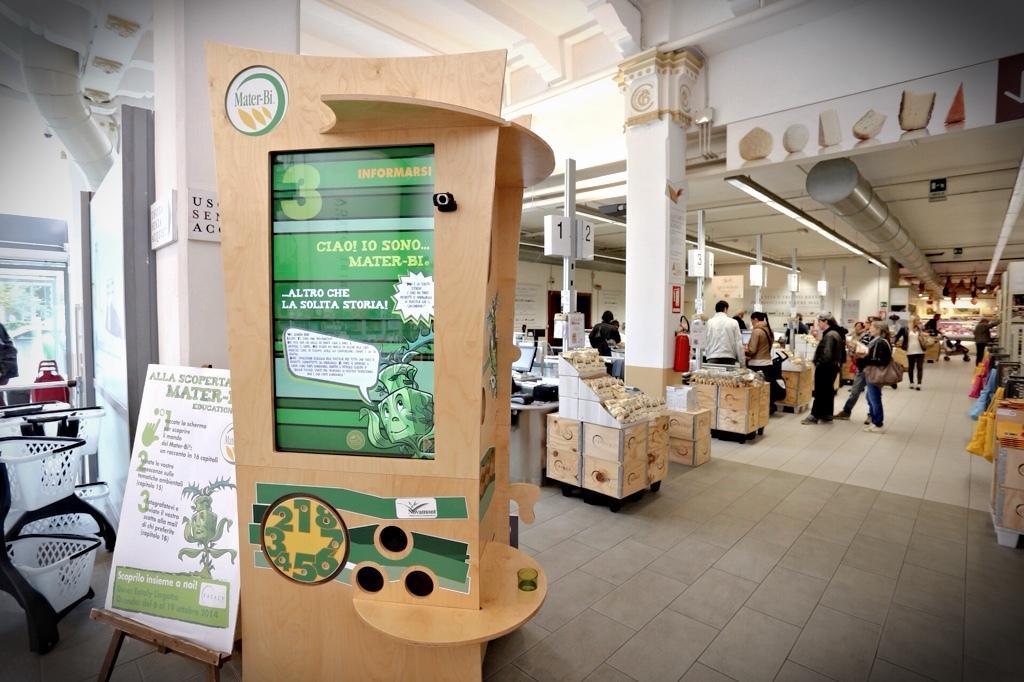Can you describe this image briefly? This is an inside view. In this image I can see many people and poles. Here I can see a wooden box on which there are few posters with some text. On the left side there are few baskets and some other objects and also there is board on which I can see the text. In the background there are few pillars. At the top of the image I can see the ceiling. There are many wooden boxes on the floor. 